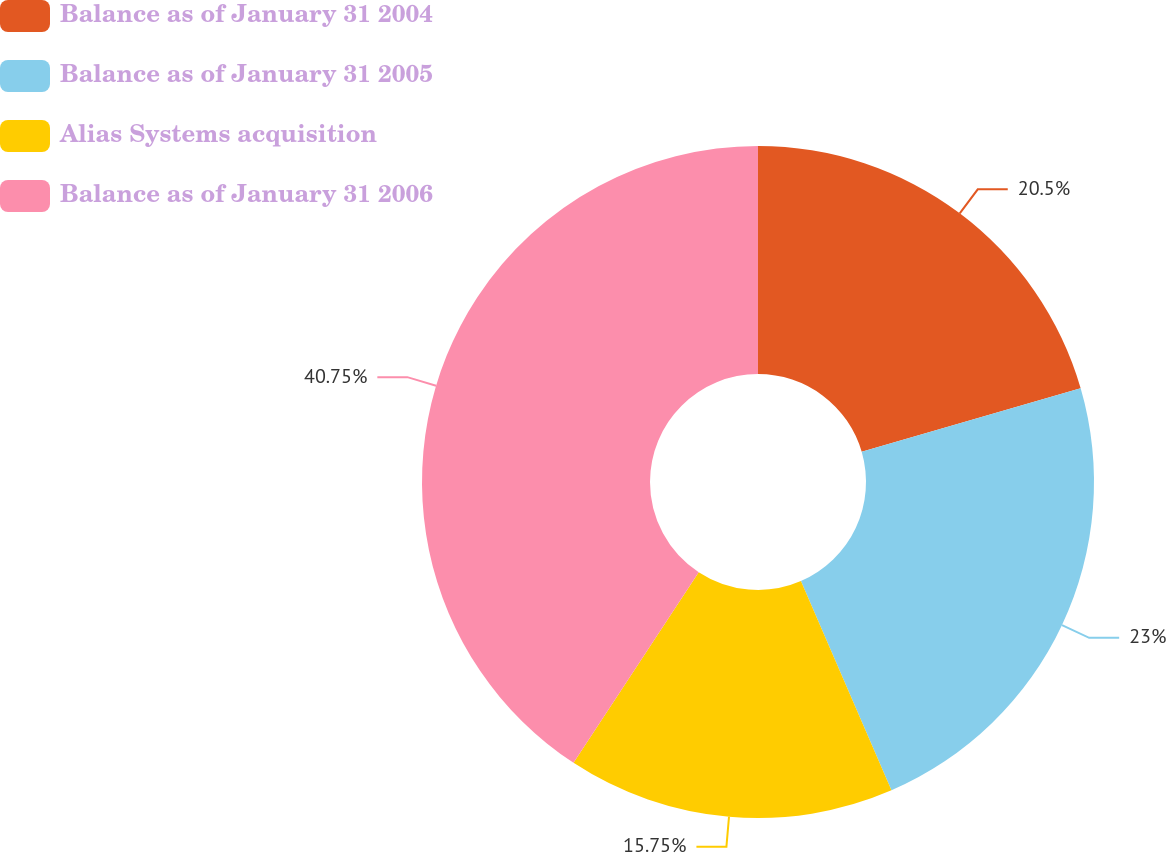<chart> <loc_0><loc_0><loc_500><loc_500><pie_chart><fcel>Balance as of January 31 2004<fcel>Balance as of January 31 2005<fcel>Alias Systems acquisition<fcel>Balance as of January 31 2006<nl><fcel>20.5%<fcel>23.0%<fcel>15.75%<fcel>40.75%<nl></chart> 